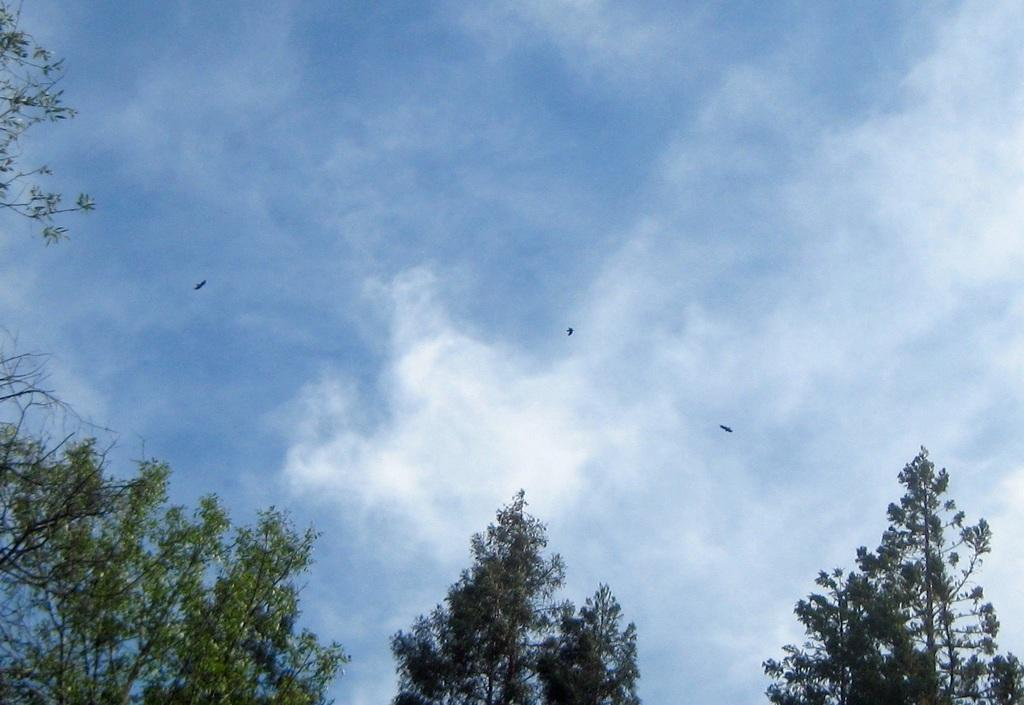What type of vegetation is present at the bottom of the image? There are trees at the bottom of the image. What can be seen in the background of the image? Birds and the sky are visible in the background of the image. How many babies are playing in the rainstorm in the image? There is no rainstorm or babies present in the image. What type of body is visible in the image? There is no body present in the image; it features trees, birds, and the sky. 